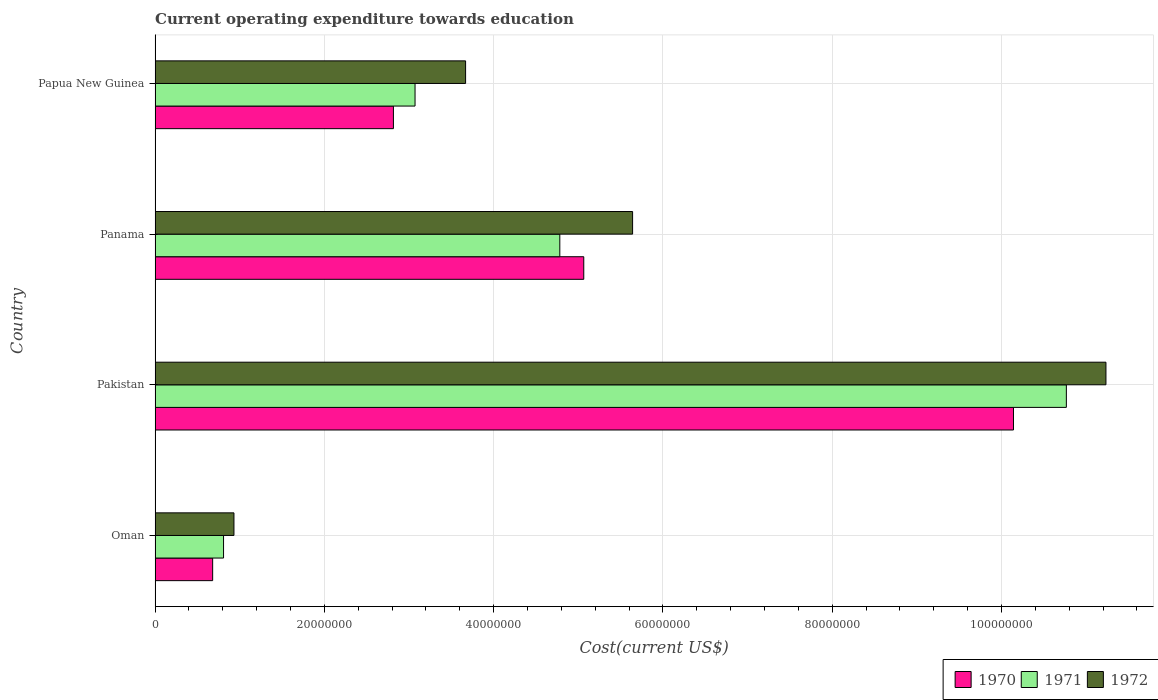How many different coloured bars are there?
Give a very brief answer. 3. Are the number of bars on each tick of the Y-axis equal?
Ensure brevity in your answer.  Yes. How many bars are there on the 1st tick from the top?
Provide a short and direct response. 3. What is the label of the 1st group of bars from the top?
Your response must be concise. Papua New Guinea. In how many cases, is the number of bars for a given country not equal to the number of legend labels?
Your answer should be compact. 0. What is the expenditure towards education in 1970 in Oman?
Provide a short and direct response. 6.80e+06. Across all countries, what is the maximum expenditure towards education in 1970?
Keep it short and to the point. 1.01e+08. Across all countries, what is the minimum expenditure towards education in 1972?
Your answer should be compact. 9.32e+06. In which country was the expenditure towards education in 1970 maximum?
Ensure brevity in your answer.  Pakistan. In which country was the expenditure towards education in 1972 minimum?
Offer a very short reply. Oman. What is the total expenditure towards education in 1972 in the graph?
Make the answer very short. 2.15e+08. What is the difference between the expenditure towards education in 1971 in Oman and that in Papua New Guinea?
Provide a succinct answer. -2.26e+07. What is the difference between the expenditure towards education in 1970 in Panama and the expenditure towards education in 1972 in Oman?
Give a very brief answer. 4.13e+07. What is the average expenditure towards education in 1970 per country?
Keep it short and to the point. 4.68e+07. What is the difference between the expenditure towards education in 1972 and expenditure towards education in 1971 in Panama?
Provide a short and direct response. 8.60e+06. What is the ratio of the expenditure towards education in 1971 in Oman to that in Panama?
Offer a very short reply. 0.17. Is the expenditure towards education in 1972 in Oman less than that in Pakistan?
Keep it short and to the point. Yes. What is the difference between the highest and the second highest expenditure towards education in 1972?
Keep it short and to the point. 5.59e+07. What is the difference between the highest and the lowest expenditure towards education in 1970?
Your answer should be very brief. 9.46e+07. In how many countries, is the expenditure towards education in 1972 greater than the average expenditure towards education in 1972 taken over all countries?
Ensure brevity in your answer.  2. Is the sum of the expenditure towards education in 1971 in Oman and Pakistan greater than the maximum expenditure towards education in 1972 across all countries?
Ensure brevity in your answer.  Yes. What does the 2nd bar from the bottom in Papua New Guinea represents?
Ensure brevity in your answer.  1971. How many bars are there?
Provide a succinct answer. 12. How many countries are there in the graph?
Provide a short and direct response. 4. Are the values on the major ticks of X-axis written in scientific E-notation?
Make the answer very short. No. Does the graph contain any zero values?
Provide a succinct answer. No. Where does the legend appear in the graph?
Offer a terse response. Bottom right. What is the title of the graph?
Give a very brief answer. Current operating expenditure towards education. Does "1983" appear as one of the legend labels in the graph?
Ensure brevity in your answer.  No. What is the label or title of the X-axis?
Your answer should be compact. Cost(current US$). What is the label or title of the Y-axis?
Offer a terse response. Country. What is the Cost(current US$) in 1970 in Oman?
Your answer should be compact. 6.80e+06. What is the Cost(current US$) in 1971 in Oman?
Provide a succinct answer. 8.09e+06. What is the Cost(current US$) in 1972 in Oman?
Keep it short and to the point. 9.32e+06. What is the Cost(current US$) in 1970 in Pakistan?
Your answer should be very brief. 1.01e+08. What is the Cost(current US$) in 1971 in Pakistan?
Ensure brevity in your answer.  1.08e+08. What is the Cost(current US$) in 1972 in Pakistan?
Offer a terse response. 1.12e+08. What is the Cost(current US$) of 1970 in Panama?
Offer a very short reply. 5.07e+07. What is the Cost(current US$) of 1971 in Panama?
Your answer should be compact. 4.78e+07. What is the Cost(current US$) of 1972 in Panama?
Your response must be concise. 5.64e+07. What is the Cost(current US$) of 1970 in Papua New Guinea?
Offer a very short reply. 2.82e+07. What is the Cost(current US$) in 1971 in Papua New Guinea?
Offer a very short reply. 3.07e+07. What is the Cost(current US$) of 1972 in Papua New Guinea?
Make the answer very short. 3.67e+07. Across all countries, what is the maximum Cost(current US$) in 1970?
Provide a short and direct response. 1.01e+08. Across all countries, what is the maximum Cost(current US$) in 1971?
Your answer should be compact. 1.08e+08. Across all countries, what is the maximum Cost(current US$) in 1972?
Provide a short and direct response. 1.12e+08. Across all countries, what is the minimum Cost(current US$) of 1970?
Your answer should be very brief. 6.80e+06. Across all countries, what is the minimum Cost(current US$) in 1971?
Give a very brief answer. 8.09e+06. Across all countries, what is the minimum Cost(current US$) in 1972?
Give a very brief answer. 9.32e+06. What is the total Cost(current US$) of 1970 in the graph?
Provide a succinct answer. 1.87e+08. What is the total Cost(current US$) in 1971 in the graph?
Make the answer very short. 1.94e+08. What is the total Cost(current US$) of 1972 in the graph?
Your answer should be compact. 2.15e+08. What is the difference between the Cost(current US$) of 1970 in Oman and that in Pakistan?
Keep it short and to the point. -9.46e+07. What is the difference between the Cost(current US$) of 1971 in Oman and that in Pakistan?
Your answer should be very brief. -9.96e+07. What is the difference between the Cost(current US$) in 1972 in Oman and that in Pakistan?
Make the answer very short. -1.03e+08. What is the difference between the Cost(current US$) in 1970 in Oman and that in Panama?
Offer a terse response. -4.38e+07. What is the difference between the Cost(current US$) in 1971 in Oman and that in Panama?
Your response must be concise. -3.97e+07. What is the difference between the Cost(current US$) of 1972 in Oman and that in Panama?
Your response must be concise. -4.71e+07. What is the difference between the Cost(current US$) of 1970 in Oman and that in Papua New Guinea?
Offer a terse response. -2.14e+07. What is the difference between the Cost(current US$) in 1971 in Oman and that in Papua New Guinea?
Ensure brevity in your answer.  -2.26e+07. What is the difference between the Cost(current US$) in 1972 in Oman and that in Papua New Guinea?
Your answer should be compact. -2.74e+07. What is the difference between the Cost(current US$) in 1970 in Pakistan and that in Panama?
Your answer should be very brief. 5.08e+07. What is the difference between the Cost(current US$) in 1971 in Pakistan and that in Panama?
Your response must be concise. 5.98e+07. What is the difference between the Cost(current US$) of 1972 in Pakistan and that in Panama?
Keep it short and to the point. 5.59e+07. What is the difference between the Cost(current US$) of 1970 in Pakistan and that in Papua New Guinea?
Provide a short and direct response. 7.33e+07. What is the difference between the Cost(current US$) in 1971 in Pakistan and that in Papua New Guinea?
Give a very brief answer. 7.70e+07. What is the difference between the Cost(current US$) in 1972 in Pakistan and that in Papua New Guinea?
Your answer should be compact. 7.57e+07. What is the difference between the Cost(current US$) in 1970 in Panama and that in Papua New Guinea?
Your answer should be compact. 2.25e+07. What is the difference between the Cost(current US$) in 1971 in Panama and that in Papua New Guinea?
Offer a very short reply. 1.71e+07. What is the difference between the Cost(current US$) of 1972 in Panama and that in Papua New Guinea?
Offer a terse response. 1.97e+07. What is the difference between the Cost(current US$) of 1970 in Oman and the Cost(current US$) of 1971 in Pakistan?
Your answer should be compact. -1.01e+08. What is the difference between the Cost(current US$) in 1970 in Oman and the Cost(current US$) in 1972 in Pakistan?
Keep it short and to the point. -1.06e+08. What is the difference between the Cost(current US$) in 1971 in Oman and the Cost(current US$) in 1972 in Pakistan?
Keep it short and to the point. -1.04e+08. What is the difference between the Cost(current US$) of 1970 in Oman and the Cost(current US$) of 1971 in Panama?
Ensure brevity in your answer.  -4.10e+07. What is the difference between the Cost(current US$) of 1970 in Oman and the Cost(current US$) of 1972 in Panama?
Provide a short and direct response. -4.96e+07. What is the difference between the Cost(current US$) in 1971 in Oman and the Cost(current US$) in 1972 in Panama?
Ensure brevity in your answer.  -4.83e+07. What is the difference between the Cost(current US$) of 1970 in Oman and the Cost(current US$) of 1971 in Papua New Guinea?
Your response must be concise. -2.39e+07. What is the difference between the Cost(current US$) in 1970 in Oman and the Cost(current US$) in 1972 in Papua New Guinea?
Offer a terse response. -2.99e+07. What is the difference between the Cost(current US$) in 1971 in Oman and the Cost(current US$) in 1972 in Papua New Guinea?
Make the answer very short. -2.86e+07. What is the difference between the Cost(current US$) of 1970 in Pakistan and the Cost(current US$) of 1971 in Panama?
Keep it short and to the point. 5.36e+07. What is the difference between the Cost(current US$) of 1970 in Pakistan and the Cost(current US$) of 1972 in Panama?
Keep it short and to the point. 4.50e+07. What is the difference between the Cost(current US$) in 1971 in Pakistan and the Cost(current US$) in 1972 in Panama?
Your response must be concise. 5.12e+07. What is the difference between the Cost(current US$) of 1970 in Pakistan and the Cost(current US$) of 1971 in Papua New Guinea?
Provide a succinct answer. 7.07e+07. What is the difference between the Cost(current US$) in 1970 in Pakistan and the Cost(current US$) in 1972 in Papua New Guinea?
Provide a short and direct response. 6.47e+07. What is the difference between the Cost(current US$) of 1971 in Pakistan and the Cost(current US$) of 1972 in Papua New Guinea?
Give a very brief answer. 7.10e+07. What is the difference between the Cost(current US$) in 1970 in Panama and the Cost(current US$) in 1971 in Papua New Guinea?
Your answer should be very brief. 1.99e+07. What is the difference between the Cost(current US$) of 1970 in Panama and the Cost(current US$) of 1972 in Papua New Guinea?
Offer a very short reply. 1.40e+07. What is the difference between the Cost(current US$) in 1971 in Panama and the Cost(current US$) in 1972 in Papua New Guinea?
Provide a short and direct response. 1.11e+07. What is the average Cost(current US$) of 1970 per country?
Give a very brief answer. 4.68e+07. What is the average Cost(current US$) of 1971 per country?
Make the answer very short. 4.86e+07. What is the average Cost(current US$) of 1972 per country?
Make the answer very short. 5.37e+07. What is the difference between the Cost(current US$) in 1970 and Cost(current US$) in 1971 in Oman?
Your answer should be compact. -1.29e+06. What is the difference between the Cost(current US$) of 1970 and Cost(current US$) of 1972 in Oman?
Keep it short and to the point. -2.52e+06. What is the difference between the Cost(current US$) of 1971 and Cost(current US$) of 1972 in Oman?
Make the answer very short. -1.23e+06. What is the difference between the Cost(current US$) of 1970 and Cost(current US$) of 1971 in Pakistan?
Offer a terse response. -6.25e+06. What is the difference between the Cost(current US$) in 1970 and Cost(current US$) in 1972 in Pakistan?
Make the answer very short. -1.09e+07. What is the difference between the Cost(current US$) of 1971 and Cost(current US$) of 1972 in Pakistan?
Offer a terse response. -4.68e+06. What is the difference between the Cost(current US$) in 1970 and Cost(current US$) in 1971 in Panama?
Offer a terse response. 2.83e+06. What is the difference between the Cost(current US$) of 1970 and Cost(current US$) of 1972 in Panama?
Give a very brief answer. -5.77e+06. What is the difference between the Cost(current US$) in 1971 and Cost(current US$) in 1972 in Panama?
Your response must be concise. -8.60e+06. What is the difference between the Cost(current US$) of 1970 and Cost(current US$) of 1971 in Papua New Guinea?
Your answer should be compact. -2.55e+06. What is the difference between the Cost(current US$) in 1970 and Cost(current US$) in 1972 in Papua New Guinea?
Offer a very short reply. -8.53e+06. What is the difference between the Cost(current US$) of 1971 and Cost(current US$) of 1972 in Papua New Guinea?
Offer a terse response. -5.97e+06. What is the ratio of the Cost(current US$) in 1970 in Oman to that in Pakistan?
Provide a succinct answer. 0.07. What is the ratio of the Cost(current US$) in 1971 in Oman to that in Pakistan?
Provide a short and direct response. 0.08. What is the ratio of the Cost(current US$) of 1972 in Oman to that in Pakistan?
Give a very brief answer. 0.08. What is the ratio of the Cost(current US$) of 1970 in Oman to that in Panama?
Make the answer very short. 0.13. What is the ratio of the Cost(current US$) of 1971 in Oman to that in Panama?
Your answer should be very brief. 0.17. What is the ratio of the Cost(current US$) in 1972 in Oman to that in Panama?
Your answer should be very brief. 0.17. What is the ratio of the Cost(current US$) in 1970 in Oman to that in Papua New Guinea?
Make the answer very short. 0.24. What is the ratio of the Cost(current US$) in 1971 in Oman to that in Papua New Guinea?
Offer a very short reply. 0.26. What is the ratio of the Cost(current US$) of 1972 in Oman to that in Papua New Guinea?
Make the answer very short. 0.25. What is the ratio of the Cost(current US$) of 1970 in Pakistan to that in Panama?
Your response must be concise. 2. What is the ratio of the Cost(current US$) in 1971 in Pakistan to that in Panama?
Provide a succinct answer. 2.25. What is the ratio of the Cost(current US$) of 1972 in Pakistan to that in Panama?
Keep it short and to the point. 1.99. What is the ratio of the Cost(current US$) of 1970 in Pakistan to that in Papua New Guinea?
Your response must be concise. 3.6. What is the ratio of the Cost(current US$) of 1971 in Pakistan to that in Papua New Guinea?
Offer a very short reply. 3.51. What is the ratio of the Cost(current US$) in 1972 in Pakistan to that in Papua New Guinea?
Provide a succinct answer. 3.06. What is the ratio of the Cost(current US$) in 1970 in Panama to that in Papua New Guinea?
Ensure brevity in your answer.  1.8. What is the ratio of the Cost(current US$) in 1971 in Panama to that in Papua New Guinea?
Your answer should be compact. 1.56. What is the ratio of the Cost(current US$) of 1972 in Panama to that in Papua New Guinea?
Keep it short and to the point. 1.54. What is the difference between the highest and the second highest Cost(current US$) in 1970?
Make the answer very short. 5.08e+07. What is the difference between the highest and the second highest Cost(current US$) in 1971?
Provide a succinct answer. 5.98e+07. What is the difference between the highest and the second highest Cost(current US$) in 1972?
Provide a short and direct response. 5.59e+07. What is the difference between the highest and the lowest Cost(current US$) in 1970?
Provide a succinct answer. 9.46e+07. What is the difference between the highest and the lowest Cost(current US$) in 1971?
Offer a terse response. 9.96e+07. What is the difference between the highest and the lowest Cost(current US$) of 1972?
Make the answer very short. 1.03e+08. 